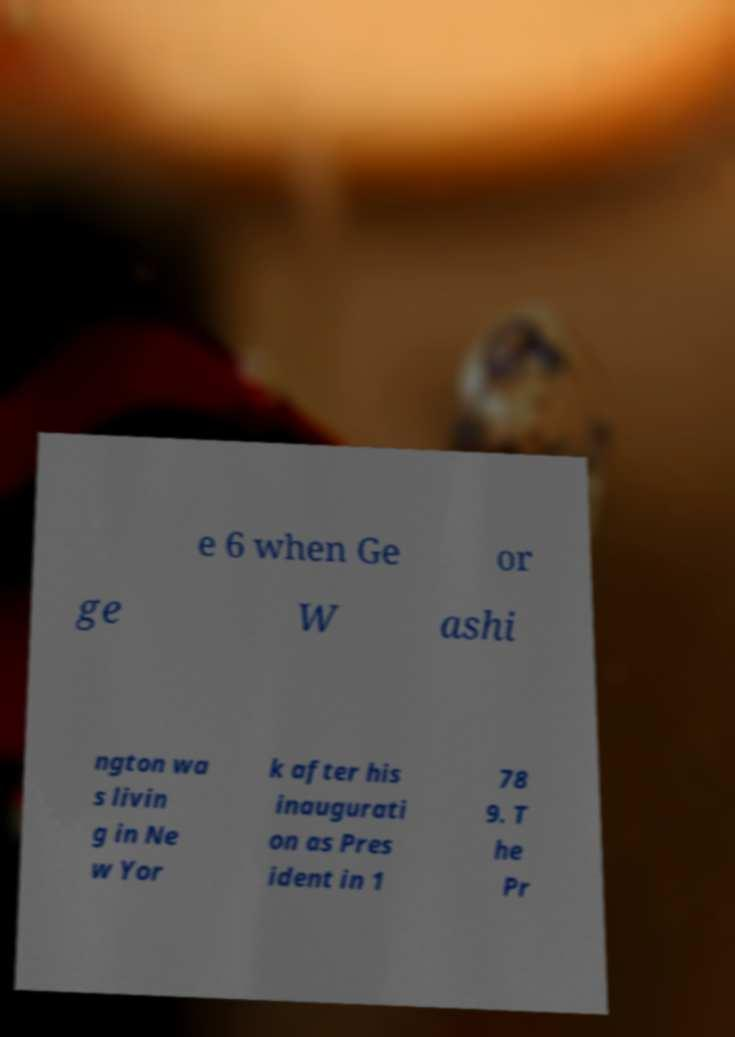I need the written content from this picture converted into text. Can you do that? e 6 when Ge or ge W ashi ngton wa s livin g in Ne w Yor k after his inaugurati on as Pres ident in 1 78 9. T he Pr 